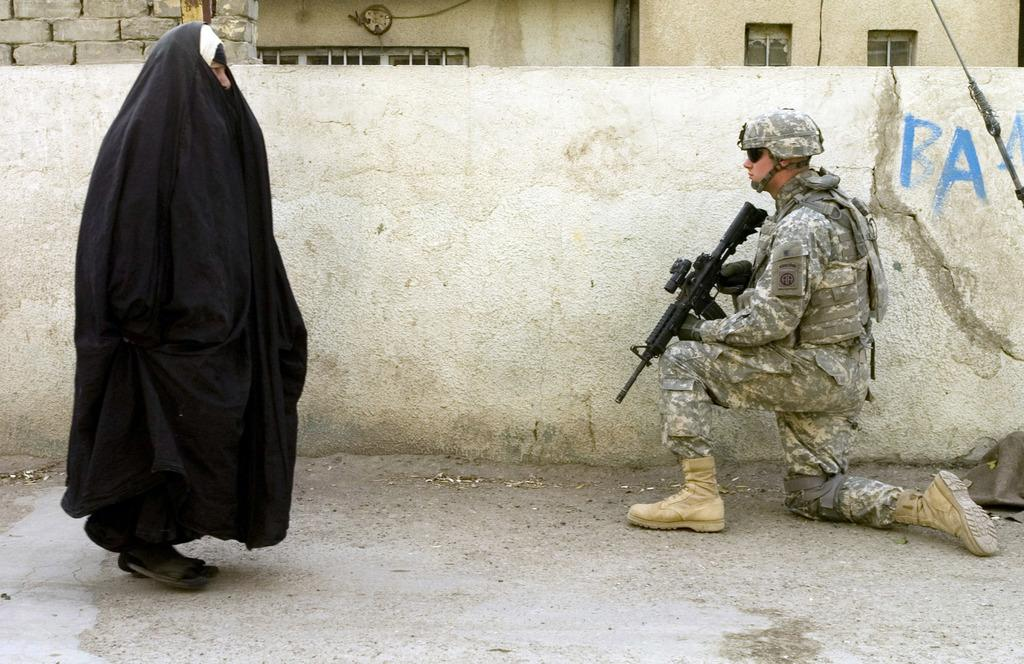How many people are in the image? There are two persons in the image. Can you describe one of the persons? One of the persons is a man, and he is on the right side of the image. What is the man holding in the image? The man is holding a gun. What can be seen in the background of the image? There is a house in the background of the image. What type of idea is the man discussing with the bear in the image? There is no bear present in the image, and therefore no discussion can be observed. How many toes can be seen on the man's foot in the image? The image does not show the man's foot, so the number of toes cannot be determined. 